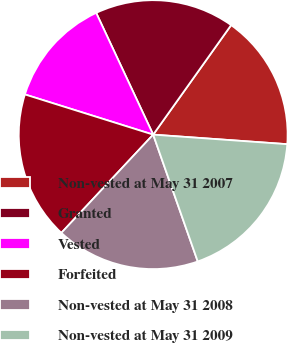Convert chart. <chart><loc_0><loc_0><loc_500><loc_500><pie_chart><fcel>Non-vested at May 31 2007<fcel>Granted<fcel>Vested<fcel>Forfeited<fcel>Non-vested at May 31 2008<fcel>Non-vested at May 31 2009<nl><fcel>16.29%<fcel>16.81%<fcel>13.2%<fcel>17.87%<fcel>17.34%<fcel>18.49%<nl></chart> 